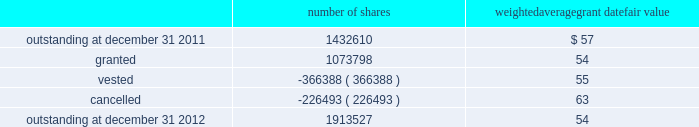The weighted average grant date fair value of options granted during 2012 , 2011 , and 2010 was $ 13 , $ 19 and $ 20 per share , respectively .
The total intrinsic value of options exercised during the years ended december 31 , 2012 , 2011 and 2010 , was $ 19.0 million , $ 4.2 million and $ 15.6 million , respectively .
In 2012 , the company granted 931340 shares of restricted class a common stock and 4048 shares of restricted stock units .
Restricted common stock and restricted stock units generally have a vesting period of 2 to 4 years .
The fair value related to these grants was $ 54.5 million , which is recognized as compensation expense on an accelerated basis over the vesting period .
Beginning with restricted stock grants in september 2010 , dividends are accrued on restricted class a common stock and restricted stock units and are paid once the restricted stock vests .
In 2012 , the company also granted 138410 performance shares .
The fair value related to these grants was $ 7.7 million , which is recognized as compensation expense on an accelerated and straight-lined basis over the vesting period .
The vesting of these shares is contingent on meeting stated performance or market conditions .
The table summarizes restricted stock , restricted stock units , and performance shares activity for 2012 : number of shares weighted average grant date fair value outstanding at december 31 , 2011 .
1432610 $ 57 .
Outstanding at december 31 , 2012 .
1913527 54 the total fair value of restricted stock , restricted stock units , and performance shares that vested during the years ended december 31 , 2012 , 2011 and 2010 , was $ 20.9 million , $ 11.6 million and $ 10.3 million , respectively .
Eligible employees may acquire shares of class a common stock using after-tax payroll deductions made during consecutive offering periods of approximately six months in duration .
Shares are purchased at the end of each offering period at a price of 90% ( 90 % ) of the closing price of the class a common stock as reported on the nasdaq global select market .
Compensation expense is recognized on the dates of purchase for the discount from the closing price .
In 2012 , 2011 and 2010 , a total of 27768 , 32085 and 21855 shares , respectively , of class a common stock were issued to participating employees .
These shares are subject to a six-month holding period .
Annual expense of $ 0.1 million , $ 0.2 million and $ 0.1 million for the purchase discount was recognized in 2012 , 2011 and 2010 , respectively .
Non-executive directors receive an annual award of class a common stock with a value equal to $ 75000 .
Non-executive directors may also elect to receive some or all of the cash portion of their annual stipend , up to $ 25000 , in shares of stock based on the closing price at the date of distribution .
As a result , 40260 , 40585 and 37350 shares of class a common stock were issued to non-executive directors during 2012 , 2011 and 2010 , respectively .
These shares are not subject to any vesting restrictions .
Expense of $ 2.2 million , $ 2.1 million and $ 2.4 million related to these stock-based payments was recognized for the years ended december 31 , 2012 , 2011 and 2010 , respectively .
19 .
Fair value measurements in general , the company uses quoted prices in active markets for identical assets to determine the fair value of marketable securities and equity investments .
Level 1 assets generally include u.s .
Treasury securities , equity securities listed in active markets , and investments in publicly traded mutual funds with quoted market prices .
If quoted prices are not available to determine fair value , the company uses other inputs that are directly observable .
Assets included in level 2 generally consist of asset- backed securities , municipal bonds , u.s .
Government agency securities and interest rate swap contracts .
Asset-backed securities , municipal bonds and u.s .
Government agency securities were measured at fair value based on matrix pricing using prices of similar securities with similar inputs such as maturity dates , interest rates and credit ratings .
The company determined the fair value of its interest rate swap contracts using standard valuation models with market-based observable inputs including forward and spot exchange rates and interest rate curves. .
What was the average number of shares of class a common stock were issued to non-executive between 2010 and 2012? 
Computations: ((((40260 + 40585) + 37350) + 3) / 2)
Answer: 59099.0. 